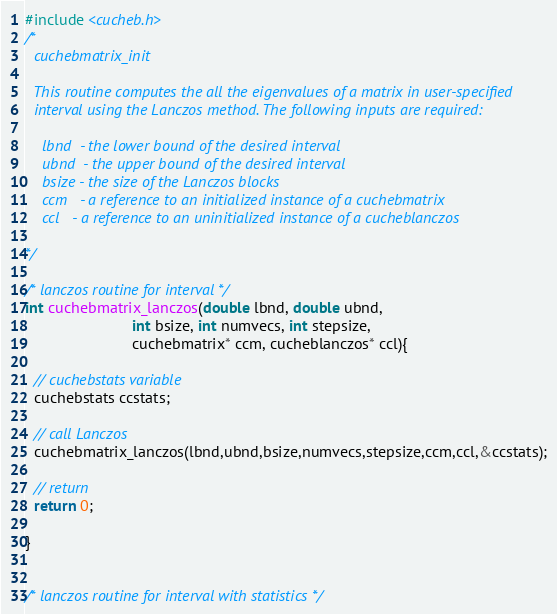<code> <loc_0><loc_0><loc_500><loc_500><_Cuda_>#include <cucheb.h>
/*
  cuchebmatrix_init

  This routine computes the all the eigenvalues of a matrix in user-specified
  interval using the Lanczos method. The following inputs are required:

    lbnd  - the lower bound of the desired interval
    ubnd  - the upper bound of the desired interval
    bsize - the size of the Lanczos blocks
    ccm   - a reference to an initialized instance of a cuchebmatrix
    ccl   - a reference to an uninitialized instance of a cucheblanczos

*/

/* lanczos routine for interval */
int cuchebmatrix_lanczos(double lbnd, double ubnd, 
                         int bsize, int numvecs, int stepsize, 
                         cuchebmatrix* ccm, cucheblanczos* ccl){

  // cuchebstats variable
  cuchebstats ccstats;

  // call Lanczos
  cuchebmatrix_lanczos(lbnd,ubnd,bsize,numvecs,stepsize,ccm,ccl,&ccstats);

  // return
  return 0;

}


/* lanczos routine for interval with statistics */</code> 